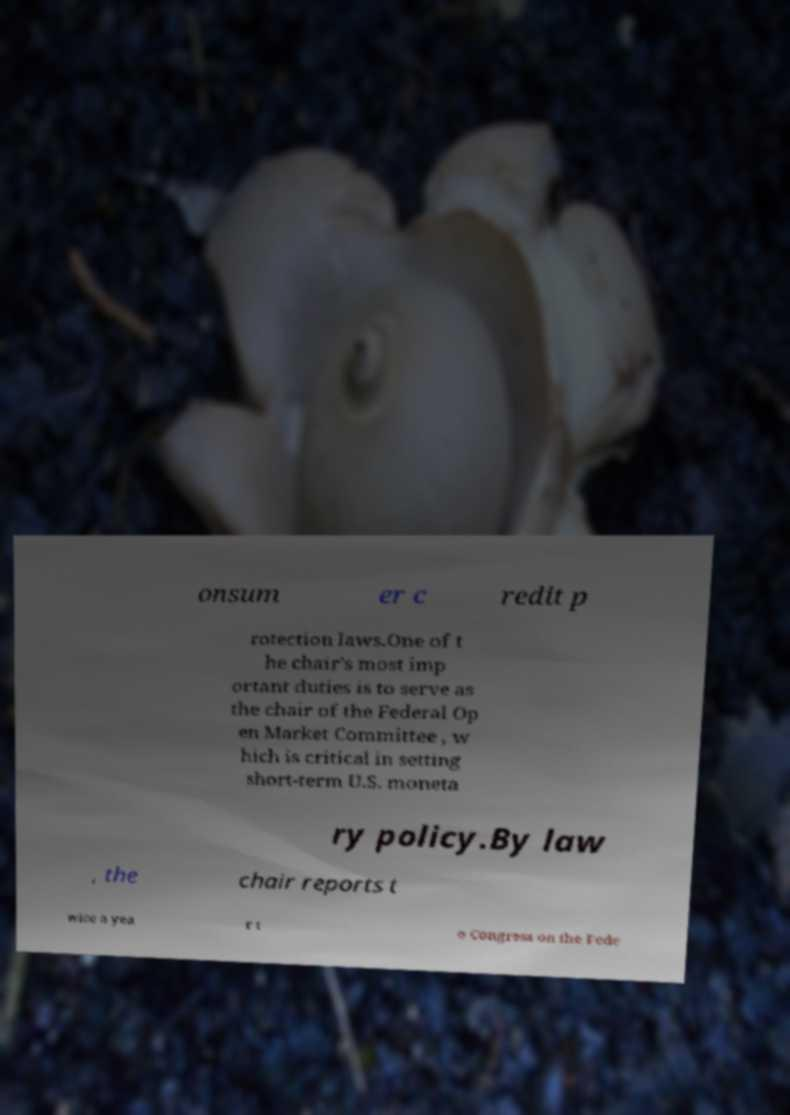For documentation purposes, I need the text within this image transcribed. Could you provide that? onsum er c redit p rotection laws.One of t he chair's most imp ortant duties is to serve as the chair of the Federal Op en Market Committee , w hich is critical in setting short-term U.S. moneta ry policy.By law , the chair reports t wice a yea r t o Congress on the Fede 